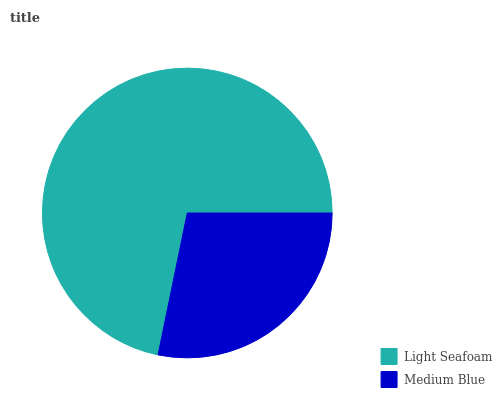Is Medium Blue the minimum?
Answer yes or no. Yes. Is Light Seafoam the maximum?
Answer yes or no. Yes. Is Medium Blue the maximum?
Answer yes or no. No. Is Light Seafoam greater than Medium Blue?
Answer yes or no. Yes. Is Medium Blue less than Light Seafoam?
Answer yes or no. Yes. Is Medium Blue greater than Light Seafoam?
Answer yes or no. No. Is Light Seafoam less than Medium Blue?
Answer yes or no. No. Is Light Seafoam the high median?
Answer yes or no. Yes. Is Medium Blue the low median?
Answer yes or no. Yes. Is Medium Blue the high median?
Answer yes or no. No. Is Light Seafoam the low median?
Answer yes or no. No. 